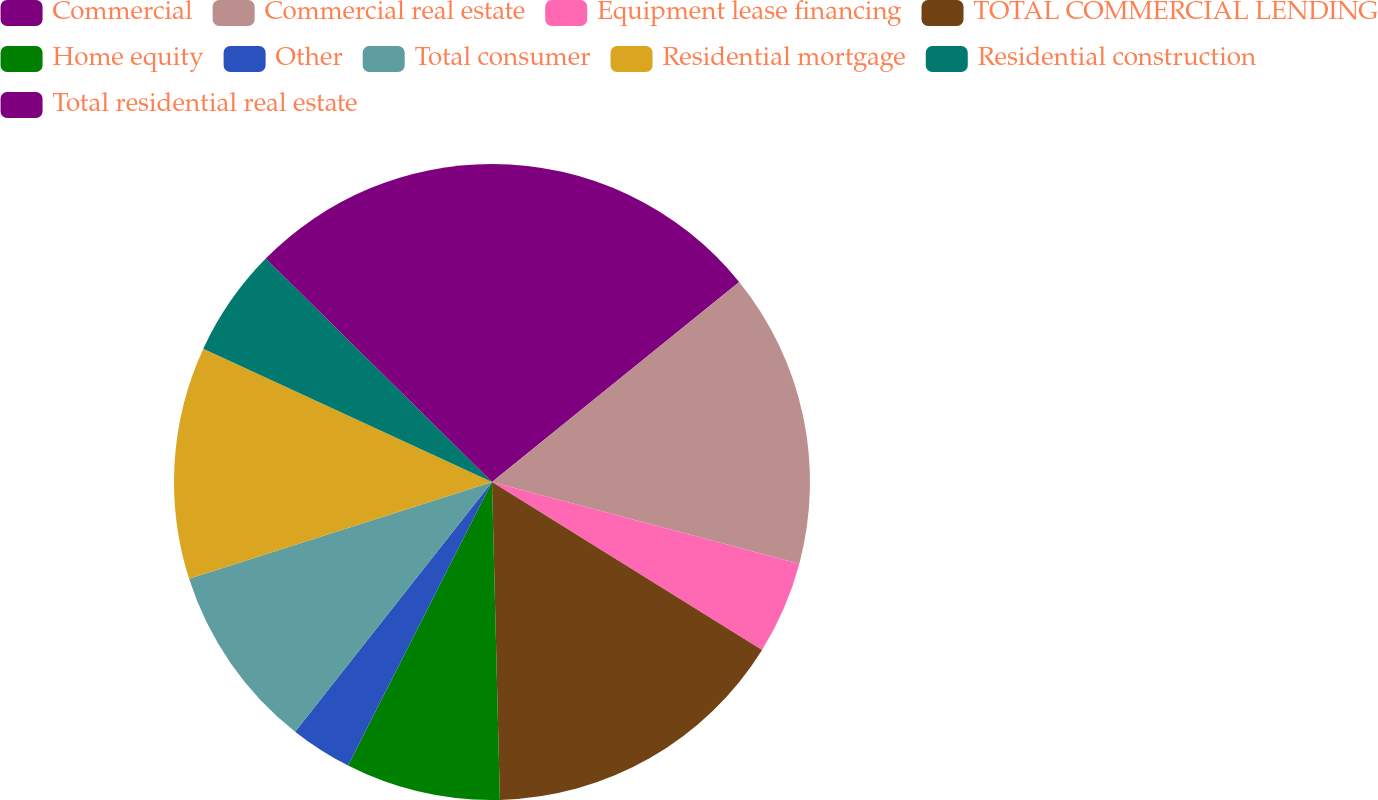Convert chart. <chart><loc_0><loc_0><loc_500><loc_500><pie_chart><fcel>Commercial<fcel>Commercial real estate<fcel>Equipment lease financing<fcel>TOTAL COMMERCIAL LENDING<fcel>Home equity<fcel>Other<fcel>Total consumer<fcel>Residential mortgage<fcel>Residential construction<fcel>Total residential real estate<nl><fcel>14.17%<fcel>14.96%<fcel>4.72%<fcel>15.75%<fcel>7.87%<fcel>3.15%<fcel>9.45%<fcel>11.81%<fcel>5.51%<fcel>12.6%<nl></chart> 